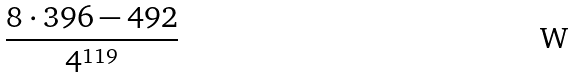<formula> <loc_0><loc_0><loc_500><loc_500>\frac { 8 \cdot 3 9 6 - 4 9 2 } { 4 ^ { 1 1 9 } }</formula> 